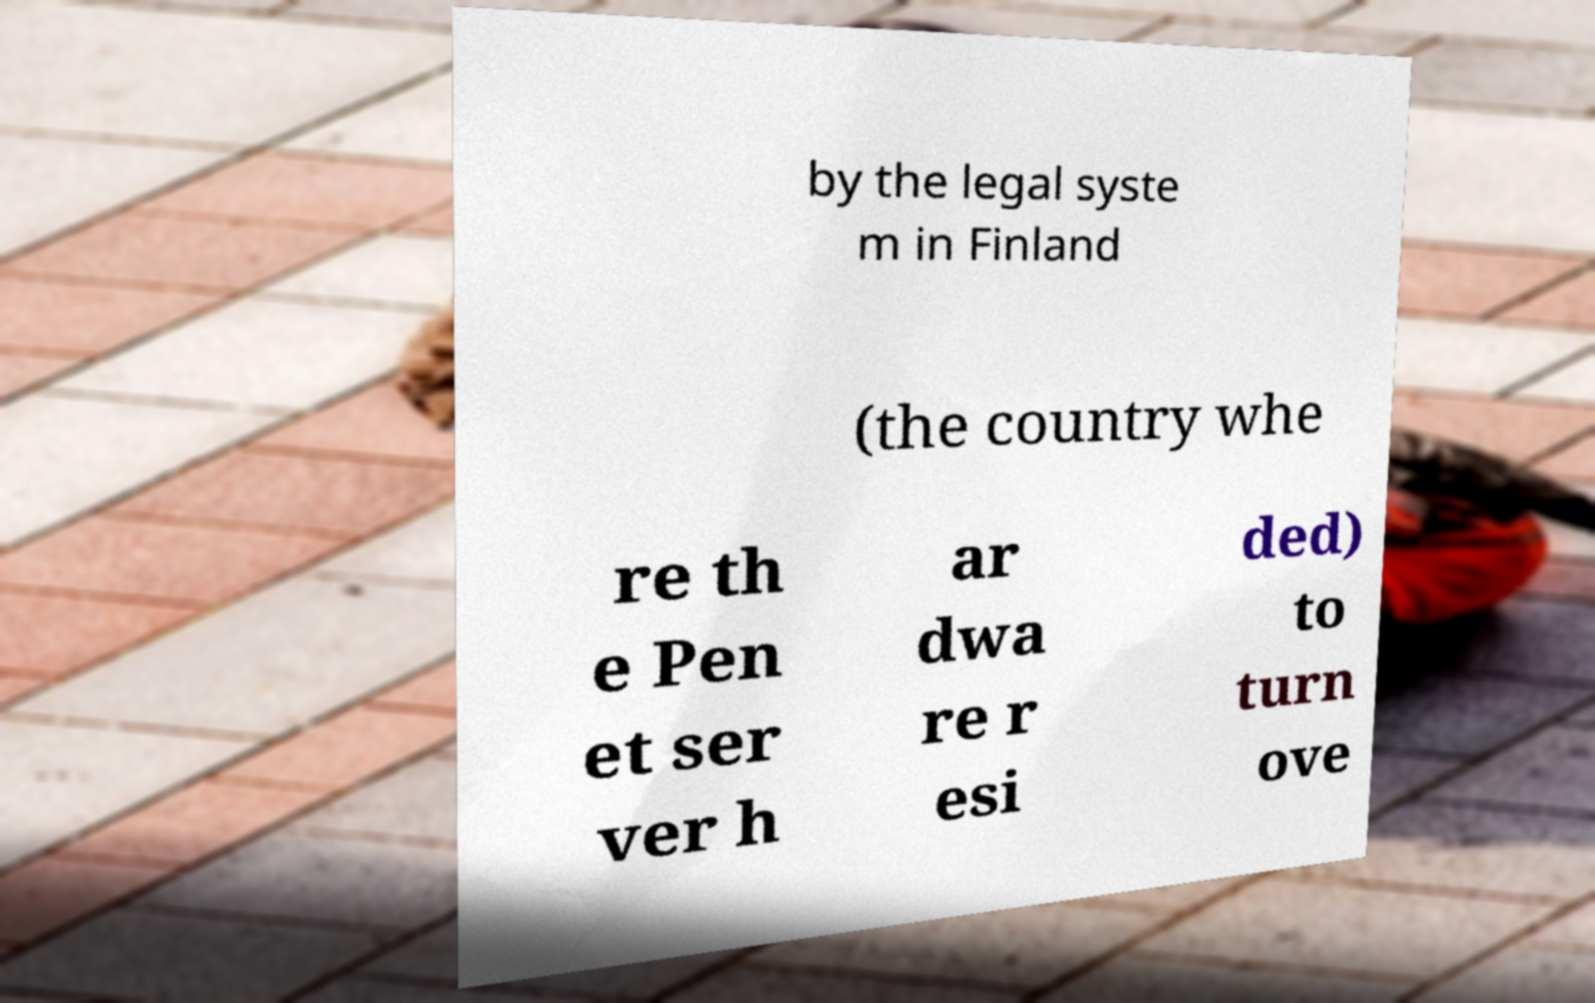For documentation purposes, I need the text within this image transcribed. Could you provide that? by the legal syste m in Finland (the country whe re th e Pen et ser ver h ar dwa re r esi ded) to turn ove 